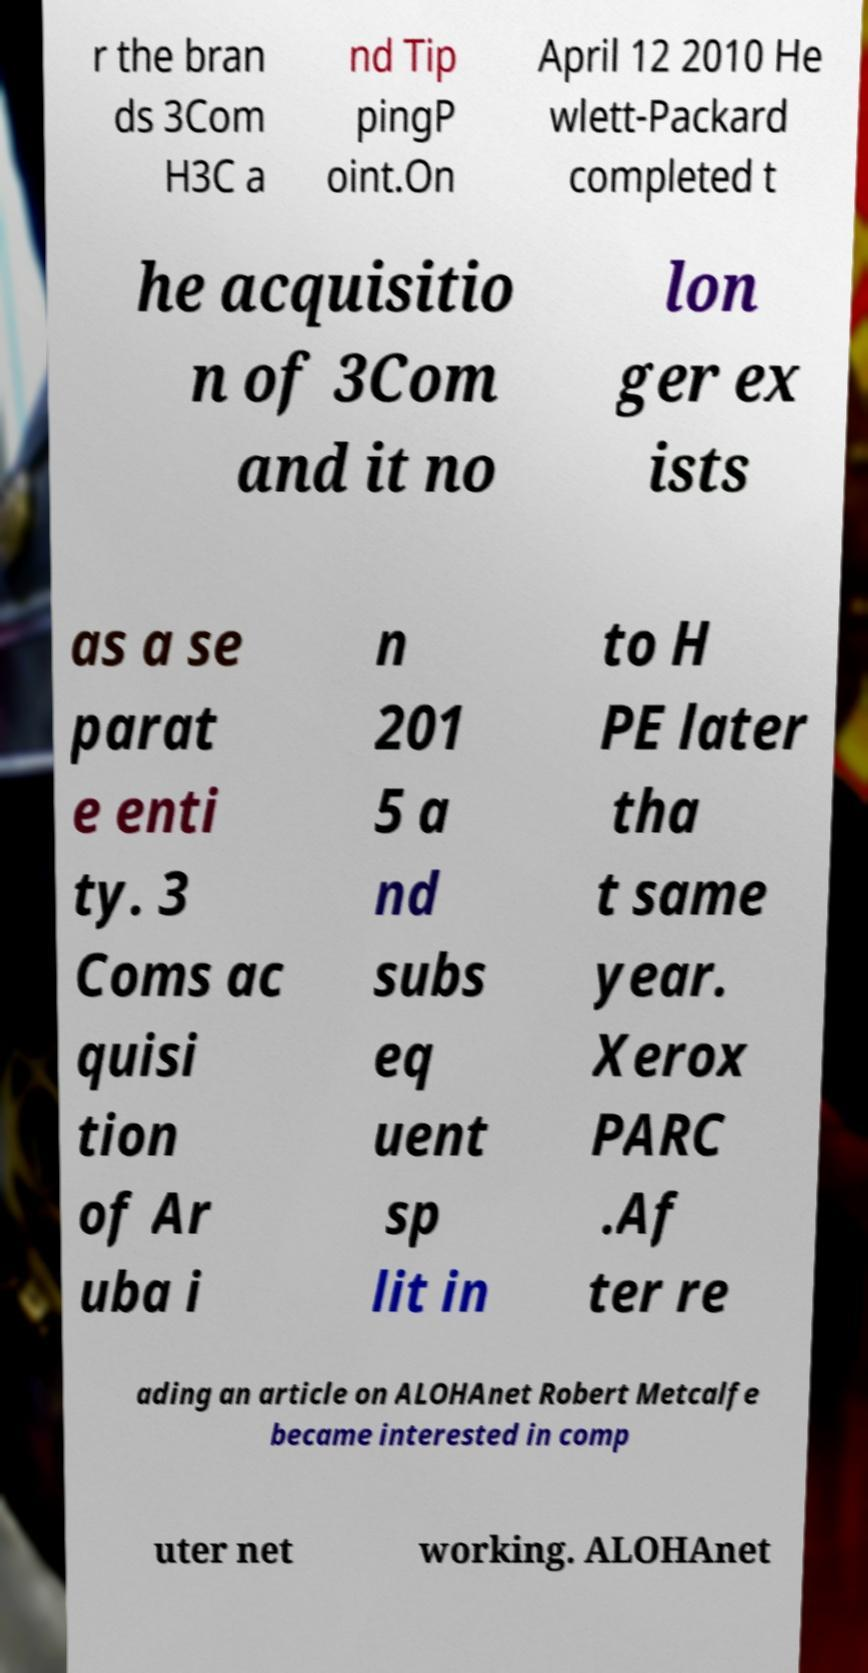I need the written content from this picture converted into text. Can you do that? r the bran ds 3Com H3C a nd Tip pingP oint.On April 12 2010 He wlett-Packard completed t he acquisitio n of 3Com and it no lon ger ex ists as a se parat e enti ty. 3 Coms ac quisi tion of Ar uba i n 201 5 a nd subs eq uent sp lit in to H PE later tha t same year. Xerox PARC .Af ter re ading an article on ALOHAnet Robert Metcalfe became interested in comp uter net working. ALOHAnet 